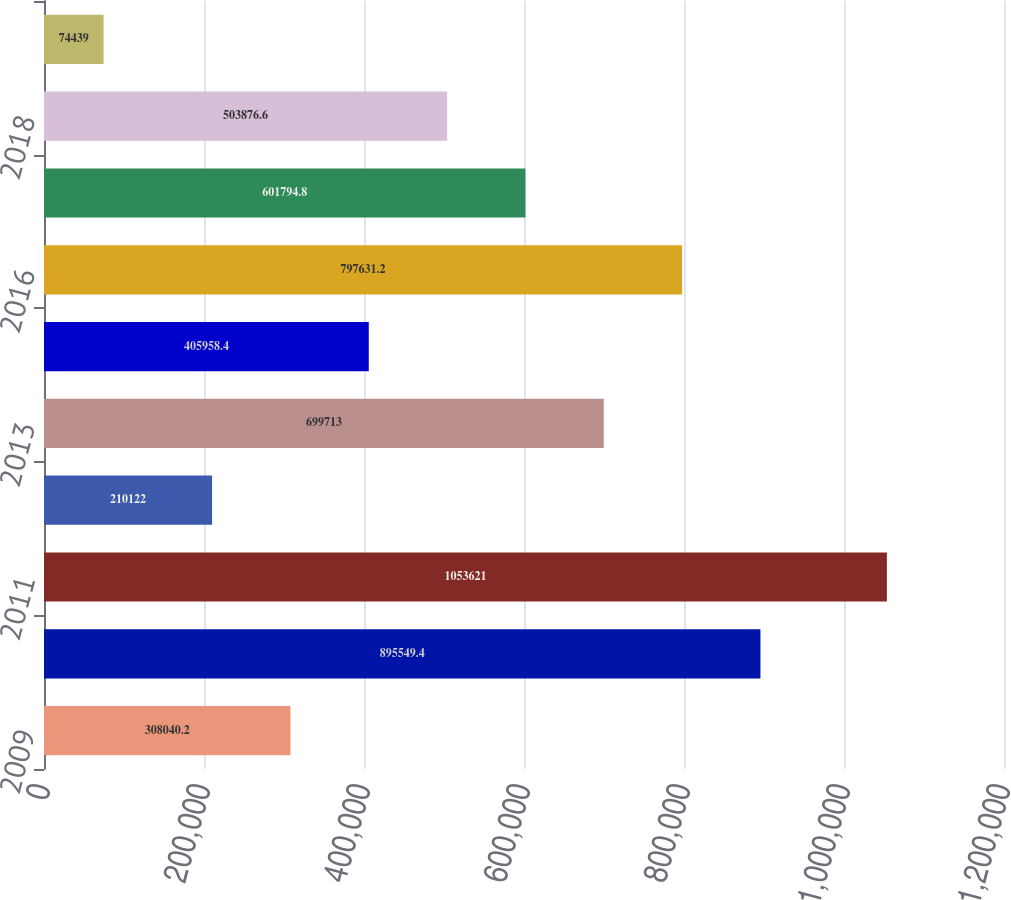Convert chart. <chart><loc_0><loc_0><loc_500><loc_500><bar_chart><fcel>2009<fcel>2010<fcel>2011<fcel>2012<fcel>2013<fcel>2014<fcel>2016<fcel>2017<fcel>2018<fcel>Thereafter<nl><fcel>308040<fcel>895549<fcel>1.05362e+06<fcel>210122<fcel>699713<fcel>405958<fcel>797631<fcel>601795<fcel>503877<fcel>74439<nl></chart> 